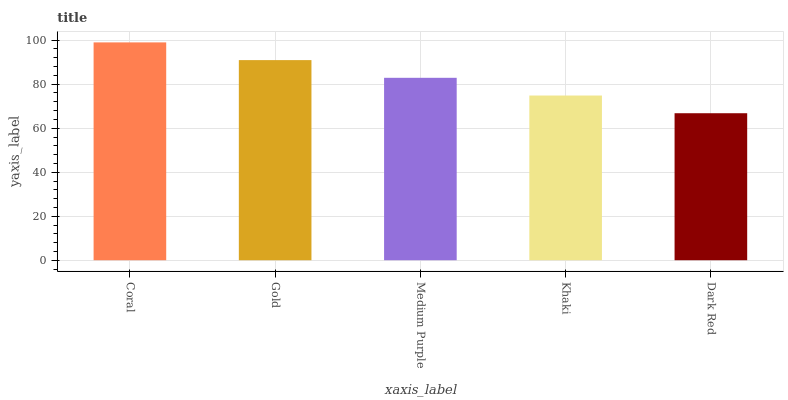Is Gold the minimum?
Answer yes or no. No. Is Gold the maximum?
Answer yes or no. No. Is Coral greater than Gold?
Answer yes or no. Yes. Is Gold less than Coral?
Answer yes or no. Yes. Is Gold greater than Coral?
Answer yes or no. No. Is Coral less than Gold?
Answer yes or no. No. Is Medium Purple the high median?
Answer yes or no. Yes. Is Medium Purple the low median?
Answer yes or no. Yes. Is Coral the high median?
Answer yes or no. No. Is Khaki the low median?
Answer yes or no. No. 